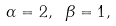<formula> <loc_0><loc_0><loc_500><loc_500>\alpha = 2 , \ \beta = 1 ,</formula> 